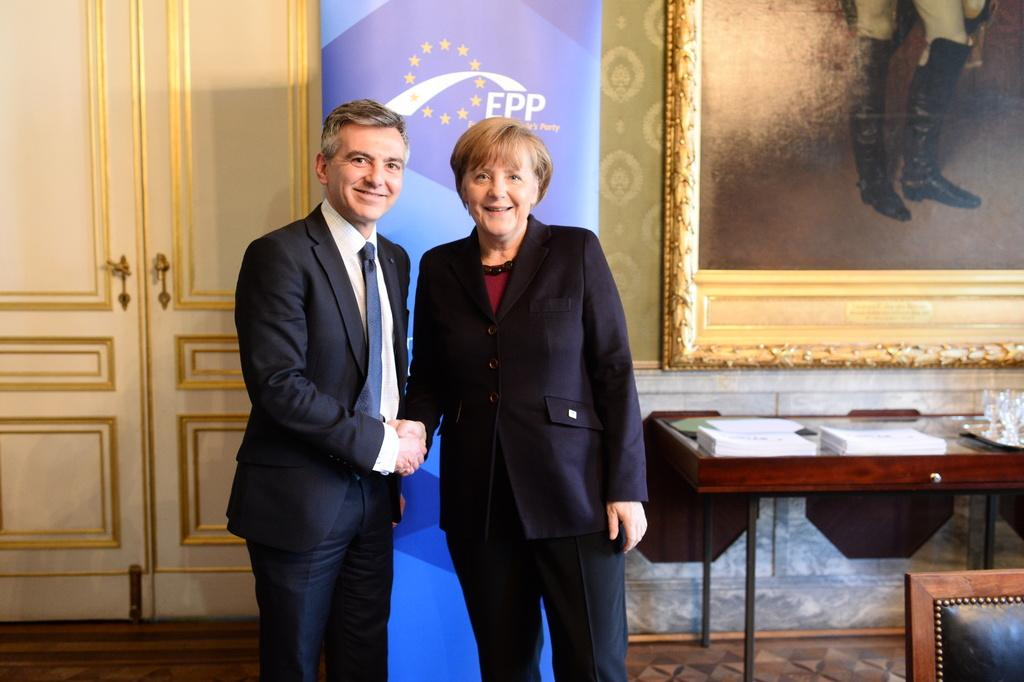Who is present in the image? There is a man and a woman in the image. What are the man and woman doing in the image? The man and woman are standing together and smiling. What can be seen on the table in the image? There are objects on the table in the image. What architectural feature is visible in the image? There is a door in the image. What is hanging on the wall in the image? There is a photo on a wall in the image. What type of humor is being expressed by the ornament in the image? There is no ornament present in the image, so it is not possible to determine what type of humor it might express. 